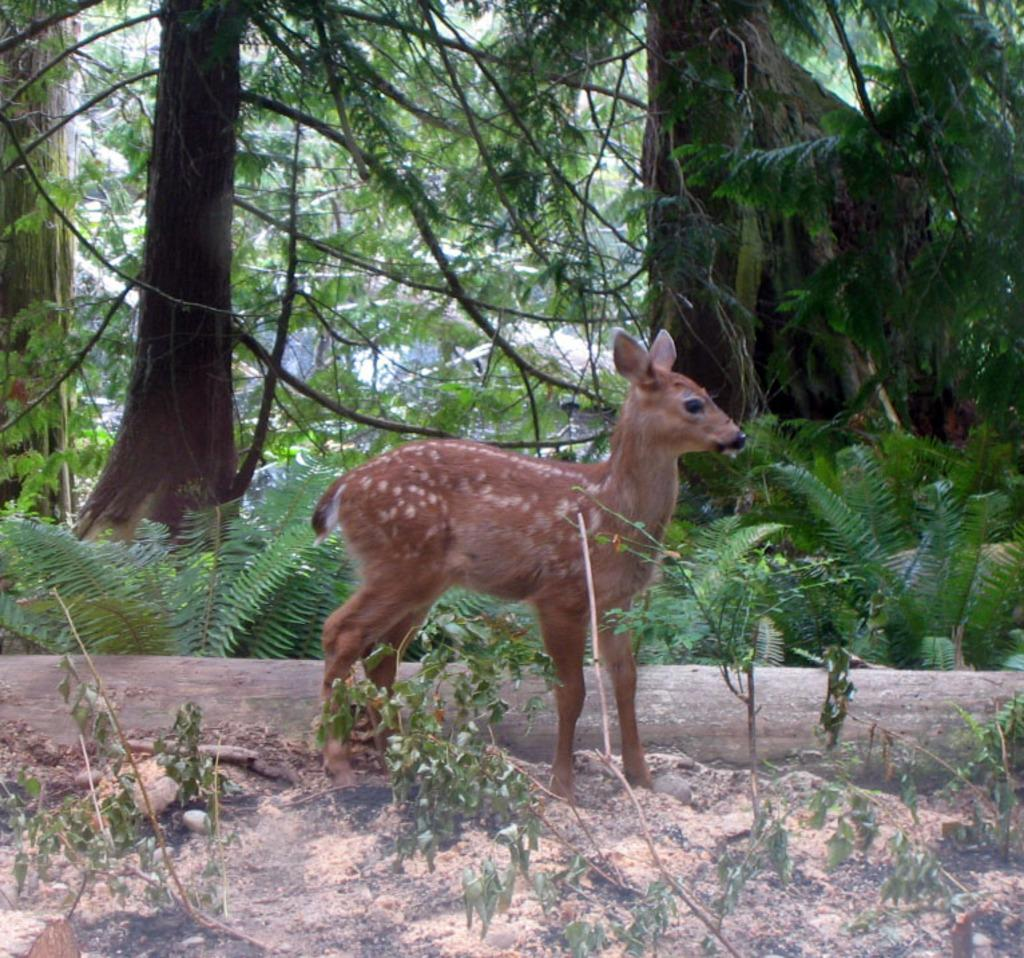What animal is located in the middle of the image? There is a deer in the middle of the image. What type of vegetation is at the bottom of the image? There are plants at the bottom of the image. What type of terrain is visible in the image? There is land visible in the image. What can be seen in the background of the image? There are trees and plants in the background of the image. What type of prose is being recited by the deer in the image? There is no indication in the image that the deer is reciting any prose. How many members are in the group of deer in the image? There is only one deer visible in the image, so it cannot be considered a group. 